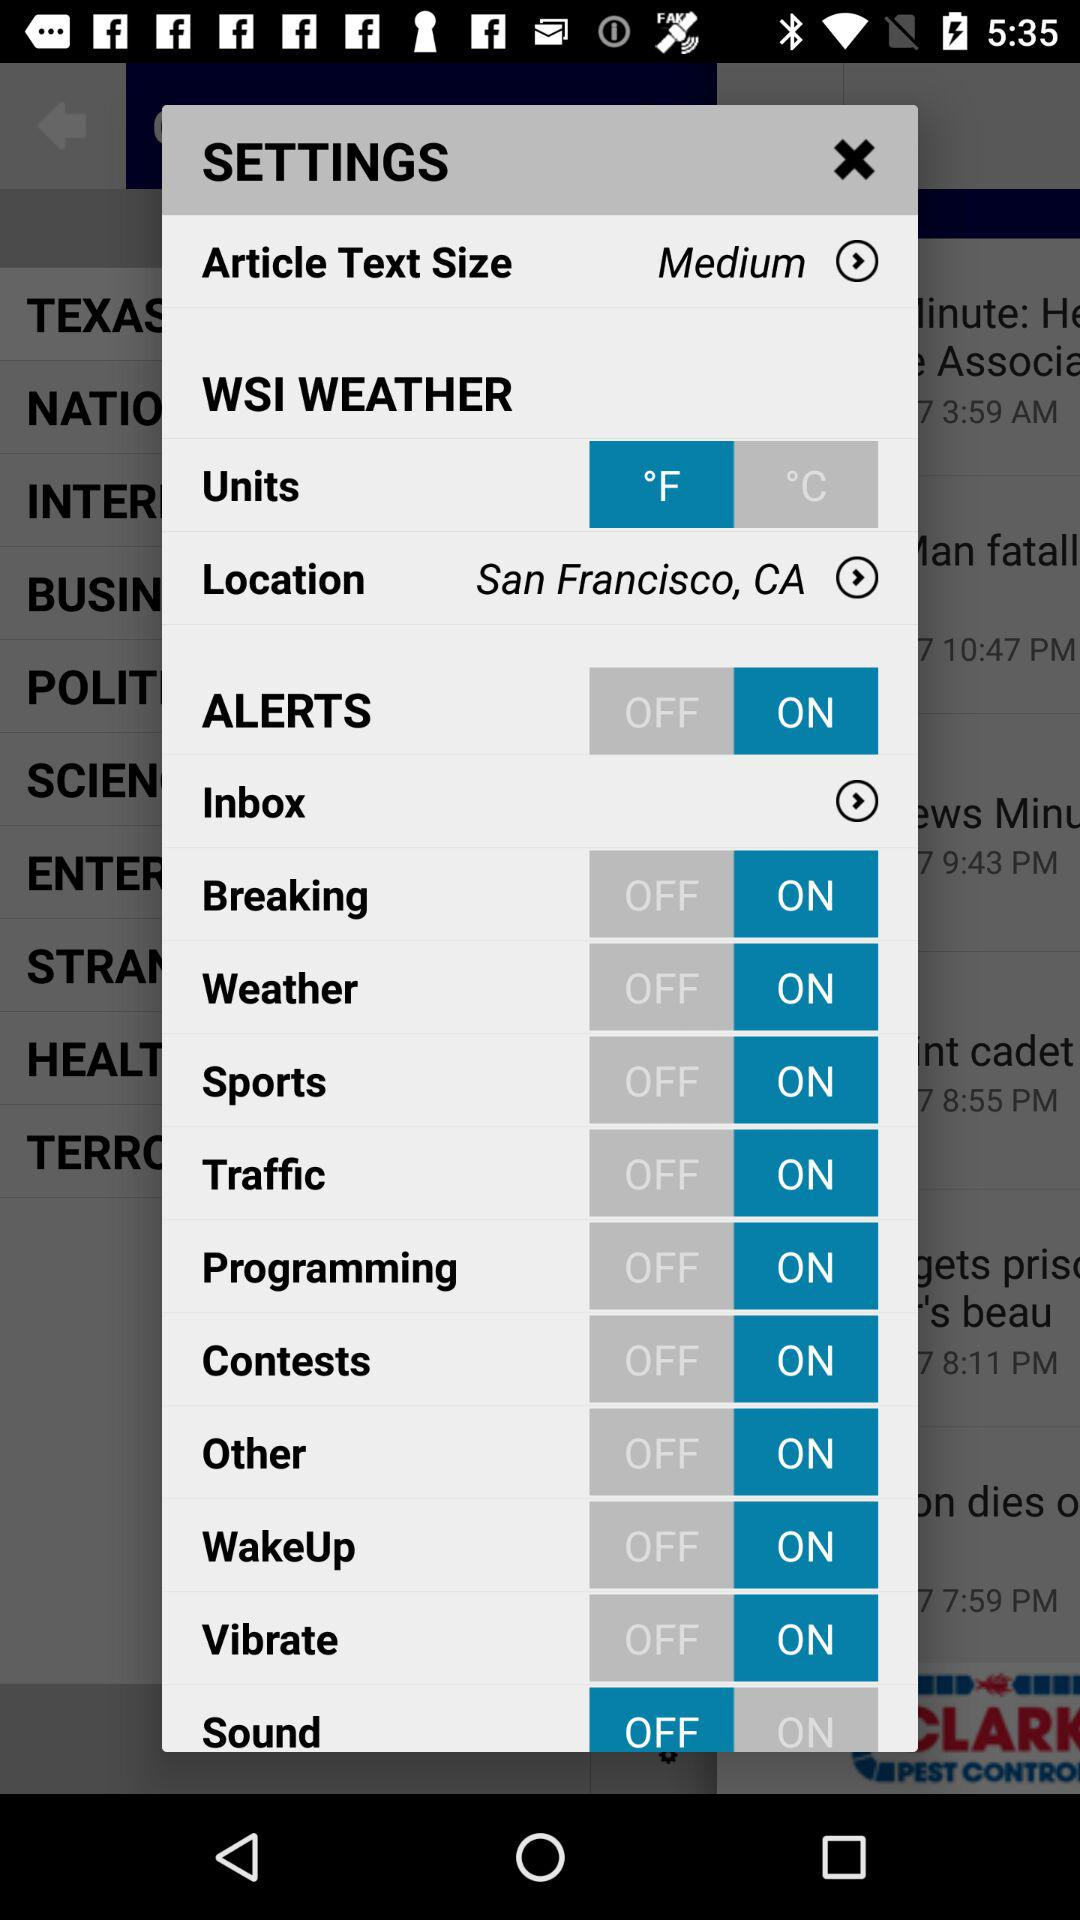What is the current location? The current location is San Francisco, CA. 